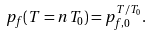<formula> <loc_0><loc_0><loc_500><loc_500>p _ { f } ( T = n T _ { 0 } ) = p _ { f , 0 } ^ { T / T _ { 0 } } .</formula> 